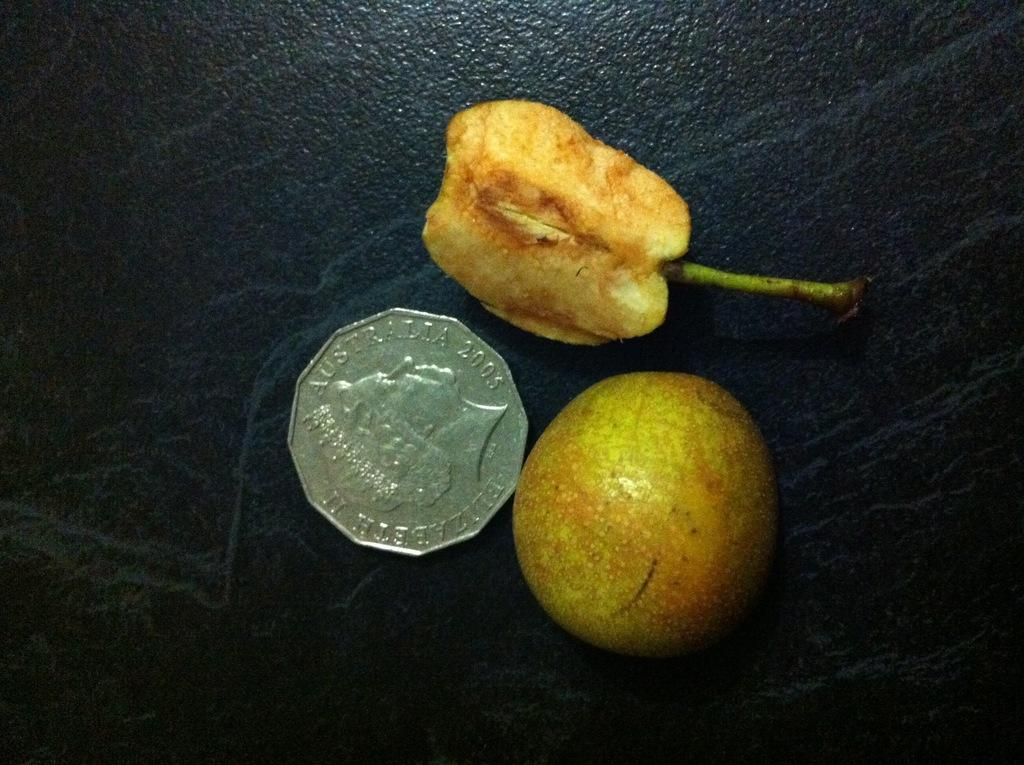What type of food items are present in the image? There are fruits in the image. What other object can be seen besides the fruits? There is a coin in the image. What is the color of the surface beneath the fruits and coin? The surface beneath the fruits and coin is black. How many chickens are present in the image? There are no chickens present in the image. What type of material is the brick used to build the wall in the image? There is no brick or wall present in the image. 